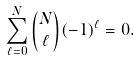Convert formula to latex. <formula><loc_0><loc_0><loc_500><loc_500>\sum ^ { N } _ { \ell = 0 } { N \choose \ell } ( - 1 ) ^ { \ell } = 0 .</formula> 